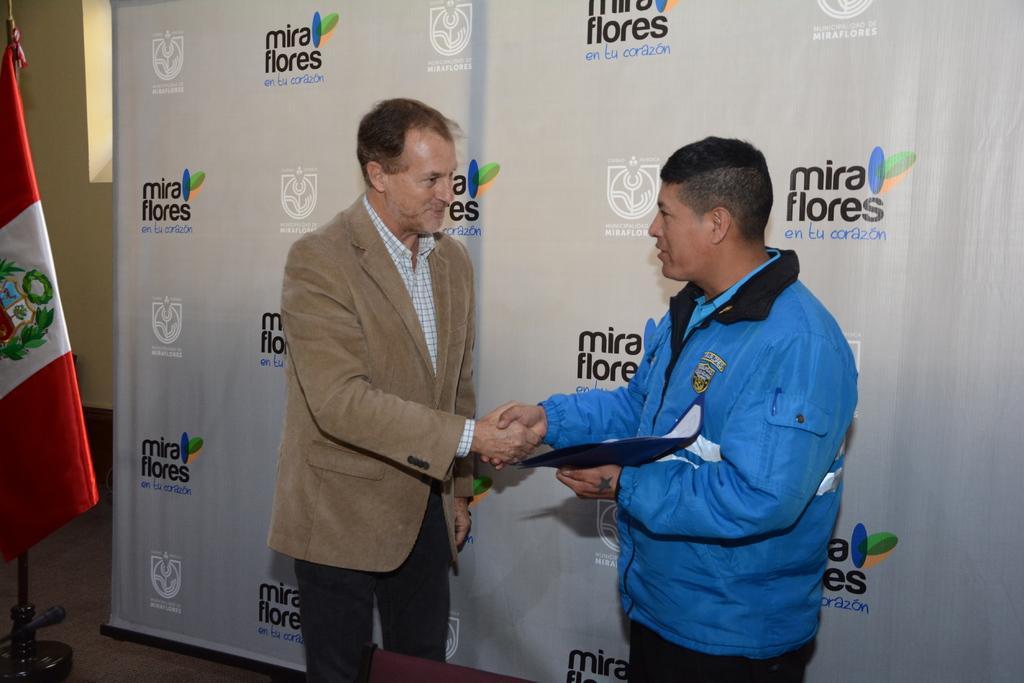Please provide a concise description of this image. In this image we can see two persons standing and facing towards each other, the person who wears the blue color shirt is holding some object in his hands, behind them there is a projector with some text, we can see a flag to the stand. 